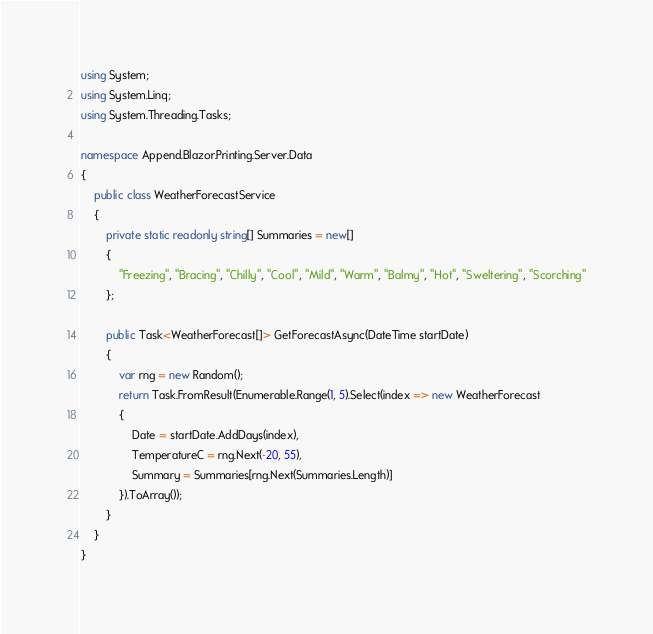<code> <loc_0><loc_0><loc_500><loc_500><_C#_>using System;
using System.Linq;
using System.Threading.Tasks;

namespace Append.Blazor.Printing.Server.Data
{
    public class WeatherForecastService
    {
        private static readonly string[] Summaries = new[]
        {
            "Freezing", "Bracing", "Chilly", "Cool", "Mild", "Warm", "Balmy", "Hot", "Sweltering", "Scorching"
        };

        public Task<WeatherForecast[]> GetForecastAsync(DateTime startDate)
        {
            var rng = new Random();
            return Task.FromResult(Enumerable.Range(1, 5).Select(index => new WeatherForecast
            {
                Date = startDate.AddDays(index),
                TemperatureC = rng.Next(-20, 55),
                Summary = Summaries[rng.Next(Summaries.Length)]
            }).ToArray());
        }
    }
}
</code> 